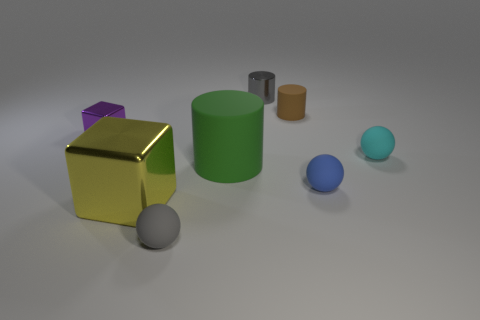Is the number of metallic cylinders that are to the right of the brown object greater than the number of large green matte things on the left side of the purple cube?
Offer a terse response. No. What material is the blue thing that is the same size as the brown cylinder?
Your answer should be very brief. Rubber. How many tiny things are either things or purple metallic blocks?
Make the answer very short. 6. Does the brown thing have the same shape as the green thing?
Your answer should be compact. Yes. How many small spheres are on the right side of the big cylinder and to the left of the big cylinder?
Provide a succinct answer. 0. Is there any other thing that is the same color as the metallic cylinder?
Provide a short and direct response. Yes. The small gray thing that is made of the same material as the cyan object is what shape?
Offer a very short reply. Sphere. Do the gray metal cylinder and the green thing have the same size?
Provide a succinct answer. No. Are the large object that is behind the yellow object and the small blue thing made of the same material?
Provide a succinct answer. Yes. How many small brown objects are behind the matte thing behind the metal block behind the blue rubber object?
Your answer should be very brief. 0. 